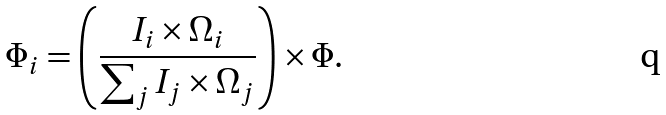<formula> <loc_0><loc_0><loc_500><loc_500>\Phi _ { i } = \left ( \frac { I _ { i } \times \Omega _ { i } } { \sum _ { j } I _ { j } \times \Omega _ { j } } \right ) \times \Phi .</formula> 